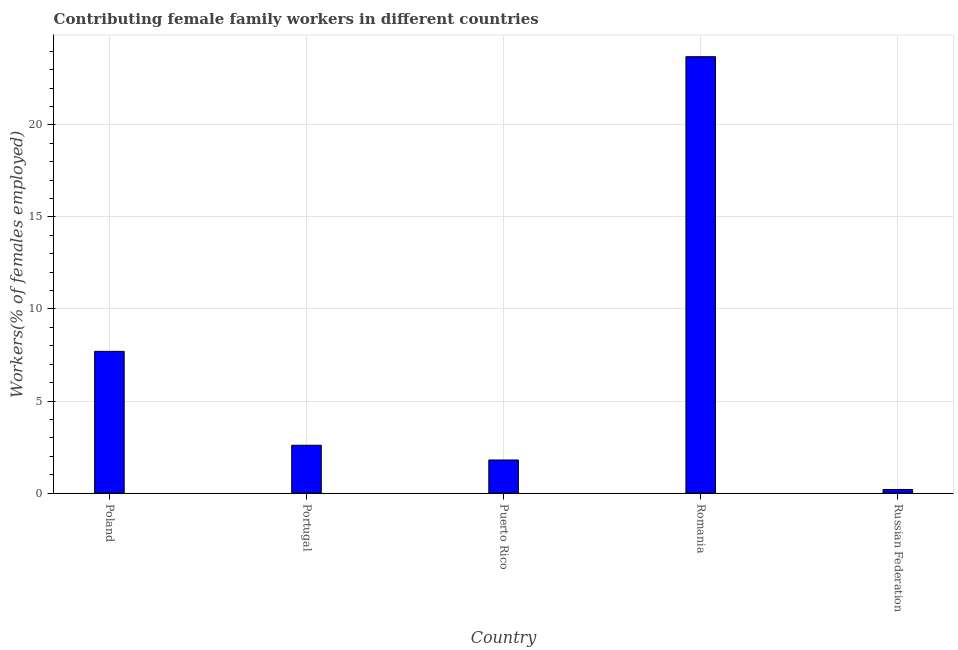Does the graph contain any zero values?
Your answer should be compact. No. What is the title of the graph?
Make the answer very short. Contributing female family workers in different countries. What is the label or title of the X-axis?
Make the answer very short. Country. What is the label or title of the Y-axis?
Your answer should be compact. Workers(% of females employed). What is the contributing female family workers in Poland?
Your answer should be very brief. 7.7. Across all countries, what is the maximum contributing female family workers?
Ensure brevity in your answer.  23.7. Across all countries, what is the minimum contributing female family workers?
Your answer should be very brief. 0.2. In which country was the contributing female family workers maximum?
Your response must be concise. Romania. In which country was the contributing female family workers minimum?
Provide a succinct answer. Russian Federation. What is the sum of the contributing female family workers?
Provide a short and direct response. 36. What is the difference between the contributing female family workers in Portugal and Romania?
Your answer should be compact. -21.1. What is the median contributing female family workers?
Offer a terse response. 2.6. In how many countries, is the contributing female family workers greater than 20 %?
Your answer should be compact. 1. What is the ratio of the contributing female family workers in Poland to that in Puerto Rico?
Your response must be concise. 4.28. Is the contributing female family workers in Portugal less than that in Romania?
Your answer should be compact. Yes. Is the difference between the contributing female family workers in Portugal and Puerto Rico greater than the difference between any two countries?
Your response must be concise. No. Is the sum of the contributing female family workers in Portugal and Romania greater than the maximum contributing female family workers across all countries?
Your answer should be very brief. Yes. What is the difference between the highest and the lowest contributing female family workers?
Give a very brief answer. 23.5. Are all the bars in the graph horizontal?
Your response must be concise. No. What is the difference between two consecutive major ticks on the Y-axis?
Your response must be concise. 5. What is the Workers(% of females employed) in Poland?
Provide a succinct answer. 7.7. What is the Workers(% of females employed) of Portugal?
Your answer should be very brief. 2.6. What is the Workers(% of females employed) of Puerto Rico?
Your answer should be very brief. 1.8. What is the Workers(% of females employed) in Romania?
Provide a succinct answer. 23.7. What is the Workers(% of females employed) of Russian Federation?
Keep it short and to the point. 0.2. What is the difference between the Workers(% of females employed) in Poland and Portugal?
Provide a succinct answer. 5.1. What is the difference between the Workers(% of females employed) in Poland and Puerto Rico?
Make the answer very short. 5.9. What is the difference between the Workers(% of females employed) in Poland and Romania?
Give a very brief answer. -16. What is the difference between the Workers(% of females employed) in Portugal and Romania?
Provide a succinct answer. -21.1. What is the difference between the Workers(% of females employed) in Portugal and Russian Federation?
Provide a succinct answer. 2.4. What is the difference between the Workers(% of females employed) in Puerto Rico and Romania?
Offer a terse response. -21.9. What is the ratio of the Workers(% of females employed) in Poland to that in Portugal?
Provide a succinct answer. 2.96. What is the ratio of the Workers(% of females employed) in Poland to that in Puerto Rico?
Offer a terse response. 4.28. What is the ratio of the Workers(% of females employed) in Poland to that in Romania?
Your answer should be very brief. 0.33. What is the ratio of the Workers(% of females employed) in Poland to that in Russian Federation?
Your response must be concise. 38.5. What is the ratio of the Workers(% of females employed) in Portugal to that in Puerto Rico?
Your answer should be very brief. 1.44. What is the ratio of the Workers(% of females employed) in Portugal to that in Romania?
Ensure brevity in your answer.  0.11. What is the ratio of the Workers(% of females employed) in Portugal to that in Russian Federation?
Your response must be concise. 13. What is the ratio of the Workers(% of females employed) in Puerto Rico to that in Romania?
Give a very brief answer. 0.08. What is the ratio of the Workers(% of females employed) in Puerto Rico to that in Russian Federation?
Give a very brief answer. 9. What is the ratio of the Workers(% of females employed) in Romania to that in Russian Federation?
Offer a terse response. 118.5. 